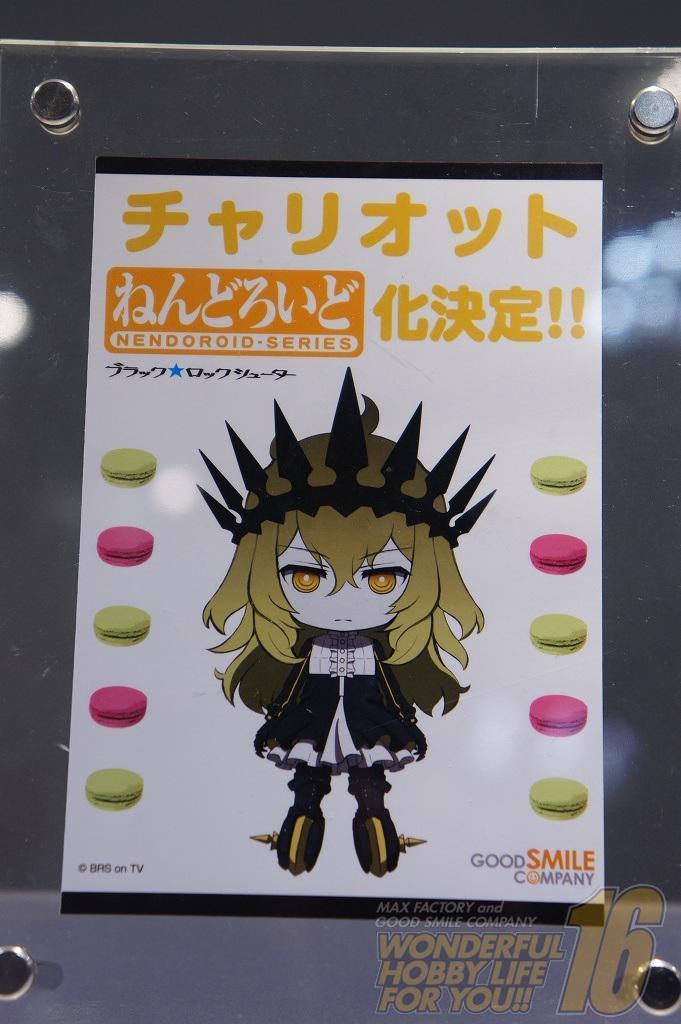Can you describe this image briefly? In the foreground of the picture there is a poster sticked on a glass. At the bottom there are holes to the glass. At the top there are bolt and hole to the glass. 